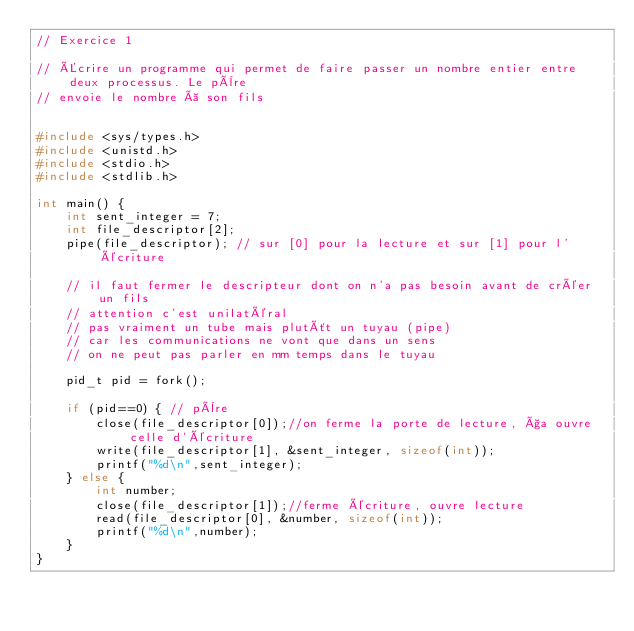<code> <loc_0><loc_0><loc_500><loc_500><_C_>// Exercice 1

// Écrire un programme qui permet de faire passer un nombre entier entre deux processus. Le père
// envoie le nombre à son fils


#include <sys/types.h>
#include <unistd.h>
#include <stdio.h>
#include <stdlib.h>

int main() {
    int sent_integer = 7;
    int file_descriptor[2];
    pipe(file_descriptor); // sur [0] pour la lecture et sur [1] pour l'écriture

    // il faut fermer le descripteur dont on n'a pas besoin avant de créer un fils
    // attention c'est unilatéral
    // pas vraiment un tube mais plutôt un tuyau (pipe)
    // car les communications ne vont que dans un sens
    // on ne peut pas parler en mm temps dans le tuyau

    pid_t pid = fork();

    if (pid==0) { // père
        close(file_descriptor[0]);//on ferme la porte de lecture, ça ouvre celle d'écriture
        write(file_descriptor[1], &sent_integer, sizeof(int));
        printf("%d\n",sent_integer);
    } else {
        int number;
        close(file_descriptor[1]);//ferme écriture, ouvre lecture
        read(file_descriptor[0], &number, sizeof(int));
        printf("%d\n",number);
    }
}</code> 